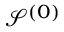Convert formula to latex. <formula><loc_0><loc_0><loc_500><loc_500>\mathcal { S } ^ { ( 0 ) }</formula> 